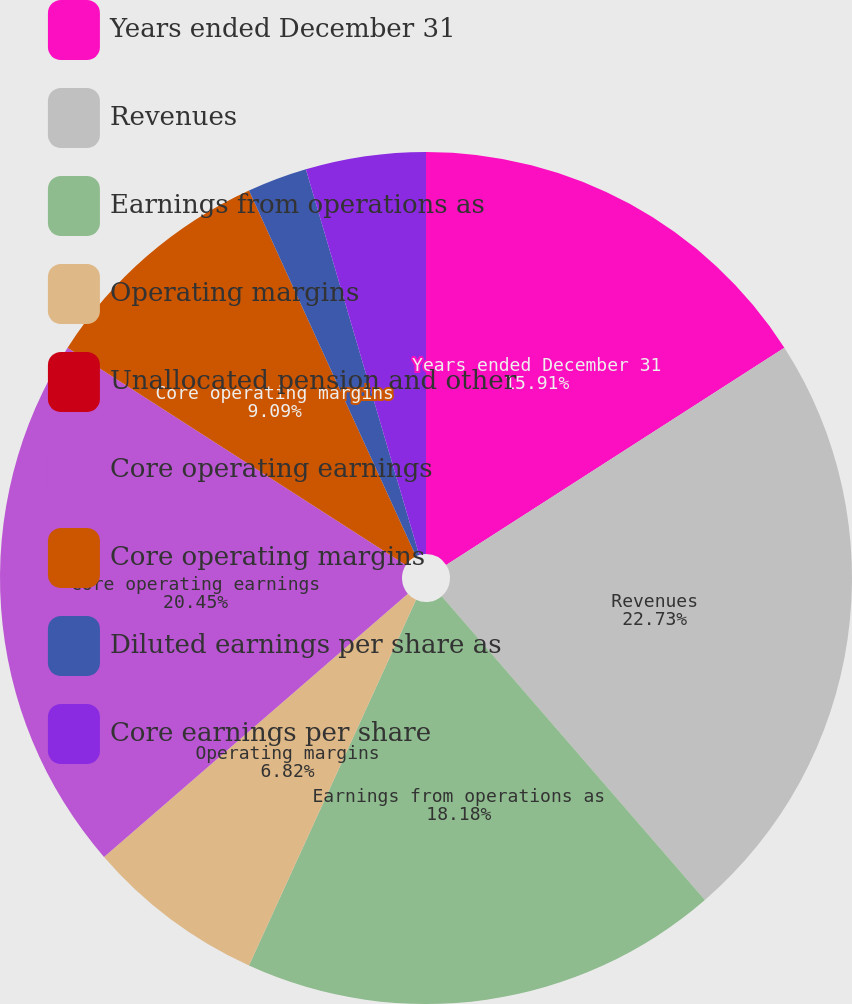Convert chart to OTSL. <chart><loc_0><loc_0><loc_500><loc_500><pie_chart><fcel>Years ended December 31<fcel>Revenues<fcel>Earnings from operations as<fcel>Operating margins<fcel>Unallocated pension and other<fcel>Core operating earnings<fcel>Core operating margins<fcel>Diluted earnings per share as<fcel>Core earnings per share<nl><fcel>15.91%<fcel>22.73%<fcel>18.18%<fcel>6.82%<fcel>0.0%<fcel>20.45%<fcel>9.09%<fcel>2.27%<fcel>4.55%<nl></chart> 